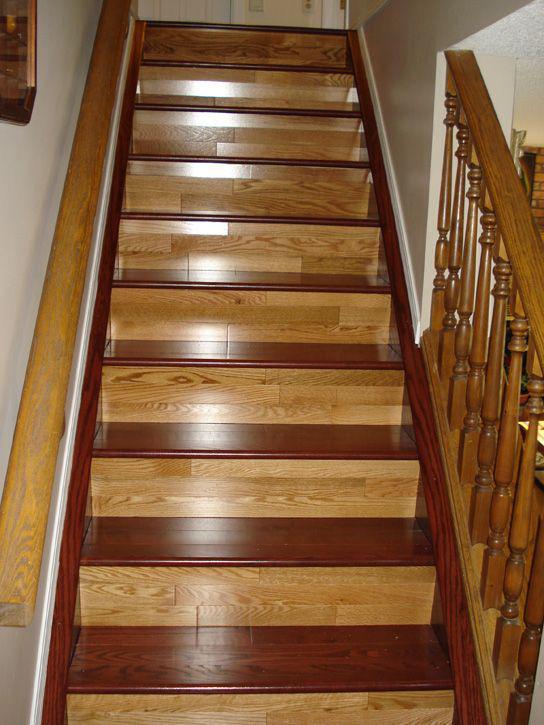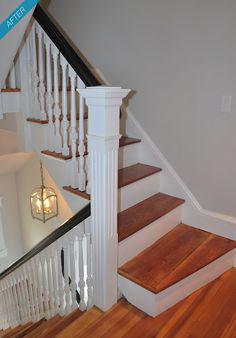The first image is the image on the left, the second image is the image on the right. Examine the images to the left and right. Is the description "One image shows a curving staircase with black steps and handrails and white spindles that ascends to a second story." accurate? Answer yes or no. No. The first image is the image on the left, the second image is the image on the right. Evaluate the accuracy of this statement regarding the images: "Some stairs are curved.". Is it true? Answer yes or no. No. 